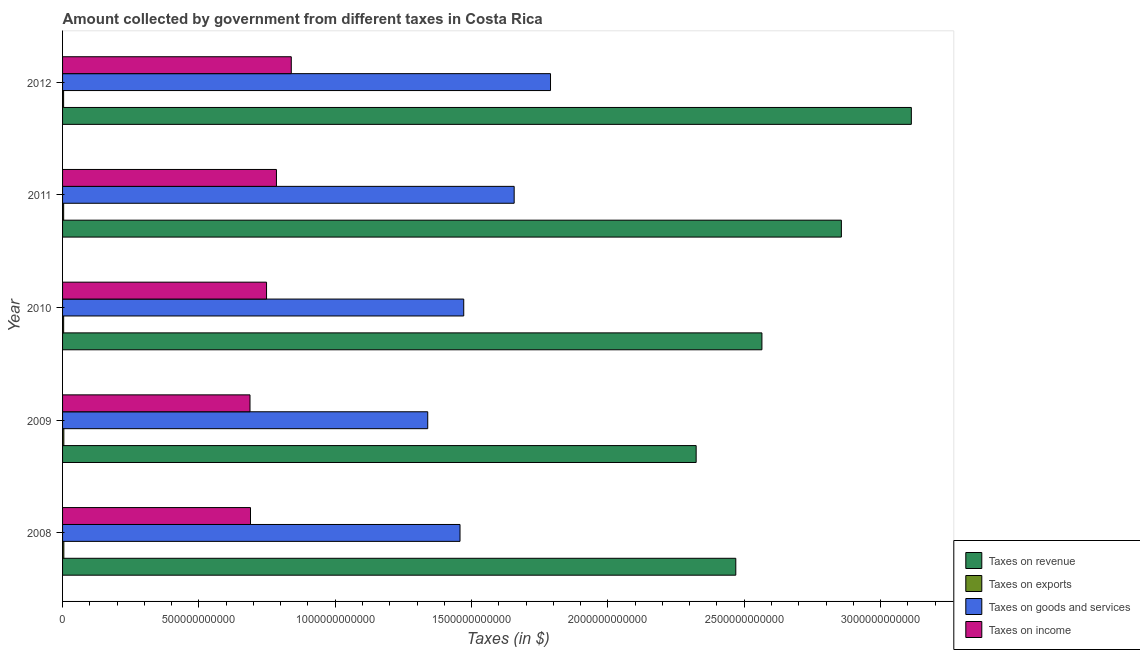How many different coloured bars are there?
Your response must be concise. 4. How many bars are there on the 1st tick from the bottom?
Keep it short and to the point. 4. What is the amount collected as tax on revenue in 2009?
Offer a terse response. 2.32e+12. Across all years, what is the maximum amount collected as tax on revenue?
Provide a succinct answer. 3.11e+12. Across all years, what is the minimum amount collected as tax on revenue?
Offer a terse response. 2.32e+12. What is the total amount collected as tax on exports in the graph?
Provide a succinct answer. 2.11e+1. What is the difference between the amount collected as tax on revenue in 2010 and that in 2011?
Your response must be concise. -2.91e+11. What is the difference between the amount collected as tax on revenue in 2012 and the amount collected as tax on income in 2011?
Your answer should be very brief. 2.33e+12. What is the average amount collected as tax on goods per year?
Provide a short and direct response. 1.54e+12. In the year 2008, what is the difference between the amount collected as tax on revenue and amount collected as tax on exports?
Your response must be concise. 2.46e+12. What is the ratio of the amount collected as tax on exports in 2010 to that in 2012?
Ensure brevity in your answer.  1.04. Is the difference between the amount collected as tax on income in 2010 and 2011 greater than the difference between the amount collected as tax on exports in 2010 and 2011?
Give a very brief answer. No. What is the difference between the highest and the second highest amount collected as tax on revenue?
Your response must be concise. 2.57e+11. What is the difference between the highest and the lowest amount collected as tax on income?
Offer a very short reply. 1.51e+11. What does the 1st bar from the top in 2009 represents?
Offer a very short reply. Taxes on income. What does the 2nd bar from the bottom in 2011 represents?
Ensure brevity in your answer.  Taxes on exports. How many bars are there?
Your answer should be very brief. 20. Are all the bars in the graph horizontal?
Make the answer very short. Yes. How many years are there in the graph?
Your answer should be compact. 5. What is the difference between two consecutive major ticks on the X-axis?
Your answer should be compact. 5.00e+11. Are the values on the major ticks of X-axis written in scientific E-notation?
Ensure brevity in your answer.  No. Does the graph contain any zero values?
Your answer should be very brief. No. Does the graph contain grids?
Make the answer very short. No. Where does the legend appear in the graph?
Give a very brief answer. Bottom right. How are the legend labels stacked?
Provide a short and direct response. Vertical. What is the title of the graph?
Offer a terse response. Amount collected by government from different taxes in Costa Rica. Does "Goods and services" appear as one of the legend labels in the graph?
Offer a very short reply. No. What is the label or title of the X-axis?
Make the answer very short. Taxes (in $). What is the Taxes (in $) in Taxes on revenue in 2008?
Provide a succinct answer. 2.47e+12. What is the Taxes (in $) of Taxes on exports in 2008?
Keep it short and to the point. 4.67e+09. What is the Taxes (in $) in Taxes on goods and services in 2008?
Offer a terse response. 1.46e+12. What is the Taxes (in $) of Taxes on income in 2008?
Your answer should be very brief. 6.89e+11. What is the Taxes (in $) of Taxes on revenue in 2009?
Make the answer very short. 2.32e+12. What is the Taxes (in $) in Taxes on exports in 2009?
Your answer should be compact. 4.68e+09. What is the Taxes (in $) in Taxes on goods and services in 2009?
Ensure brevity in your answer.  1.34e+12. What is the Taxes (in $) in Taxes on income in 2009?
Provide a succinct answer. 6.87e+11. What is the Taxes (in $) in Taxes on revenue in 2010?
Offer a very short reply. 2.56e+12. What is the Taxes (in $) in Taxes on exports in 2010?
Your response must be concise. 3.97e+09. What is the Taxes (in $) in Taxes on goods and services in 2010?
Offer a terse response. 1.47e+12. What is the Taxes (in $) in Taxes on income in 2010?
Your response must be concise. 7.48e+11. What is the Taxes (in $) of Taxes on revenue in 2011?
Keep it short and to the point. 2.86e+12. What is the Taxes (in $) of Taxes on exports in 2011?
Provide a succinct answer. 3.99e+09. What is the Taxes (in $) of Taxes on goods and services in 2011?
Keep it short and to the point. 1.66e+12. What is the Taxes (in $) in Taxes on income in 2011?
Offer a very short reply. 7.84e+11. What is the Taxes (in $) of Taxes on revenue in 2012?
Your answer should be compact. 3.11e+12. What is the Taxes (in $) in Taxes on exports in 2012?
Your answer should be very brief. 3.82e+09. What is the Taxes (in $) of Taxes on goods and services in 2012?
Make the answer very short. 1.79e+12. What is the Taxes (in $) in Taxes on income in 2012?
Provide a succinct answer. 8.39e+11. Across all years, what is the maximum Taxes (in $) of Taxes on revenue?
Provide a short and direct response. 3.11e+12. Across all years, what is the maximum Taxes (in $) in Taxes on exports?
Provide a succinct answer. 4.68e+09. Across all years, what is the maximum Taxes (in $) in Taxes on goods and services?
Your answer should be very brief. 1.79e+12. Across all years, what is the maximum Taxes (in $) of Taxes on income?
Give a very brief answer. 8.39e+11. Across all years, what is the minimum Taxes (in $) in Taxes on revenue?
Ensure brevity in your answer.  2.32e+12. Across all years, what is the minimum Taxes (in $) of Taxes on exports?
Offer a terse response. 3.82e+09. Across all years, what is the minimum Taxes (in $) of Taxes on goods and services?
Provide a short and direct response. 1.34e+12. Across all years, what is the minimum Taxes (in $) of Taxes on income?
Provide a short and direct response. 6.87e+11. What is the total Taxes (in $) in Taxes on revenue in the graph?
Give a very brief answer. 1.33e+13. What is the total Taxes (in $) of Taxes on exports in the graph?
Provide a succinct answer. 2.11e+1. What is the total Taxes (in $) in Taxes on goods and services in the graph?
Offer a terse response. 7.71e+12. What is the total Taxes (in $) in Taxes on income in the graph?
Your response must be concise. 3.75e+12. What is the difference between the Taxes (in $) in Taxes on revenue in 2008 and that in 2009?
Give a very brief answer. 1.45e+11. What is the difference between the Taxes (in $) of Taxes on exports in 2008 and that in 2009?
Offer a terse response. -9.87e+06. What is the difference between the Taxes (in $) in Taxes on goods and services in 2008 and that in 2009?
Offer a terse response. 1.18e+11. What is the difference between the Taxes (in $) of Taxes on income in 2008 and that in 2009?
Keep it short and to the point. 1.80e+09. What is the difference between the Taxes (in $) of Taxes on revenue in 2008 and that in 2010?
Ensure brevity in your answer.  -9.58e+1. What is the difference between the Taxes (in $) of Taxes on exports in 2008 and that in 2010?
Give a very brief answer. 6.95e+08. What is the difference between the Taxes (in $) in Taxes on goods and services in 2008 and that in 2010?
Keep it short and to the point. -1.36e+1. What is the difference between the Taxes (in $) in Taxes on income in 2008 and that in 2010?
Offer a very short reply. -5.89e+1. What is the difference between the Taxes (in $) in Taxes on revenue in 2008 and that in 2011?
Ensure brevity in your answer.  -3.87e+11. What is the difference between the Taxes (in $) of Taxes on exports in 2008 and that in 2011?
Offer a very short reply. 6.77e+08. What is the difference between the Taxes (in $) of Taxes on goods and services in 2008 and that in 2011?
Provide a short and direct response. -1.99e+11. What is the difference between the Taxes (in $) of Taxes on income in 2008 and that in 2011?
Make the answer very short. -9.52e+1. What is the difference between the Taxes (in $) in Taxes on revenue in 2008 and that in 2012?
Keep it short and to the point. -6.44e+11. What is the difference between the Taxes (in $) in Taxes on exports in 2008 and that in 2012?
Your answer should be compact. 8.44e+08. What is the difference between the Taxes (in $) of Taxes on goods and services in 2008 and that in 2012?
Offer a very short reply. -3.32e+11. What is the difference between the Taxes (in $) in Taxes on income in 2008 and that in 2012?
Offer a very short reply. -1.50e+11. What is the difference between the Taxes (in $) in Taxes on revenue in 2009 and that in 2010?
Make the answer very short. -2.41e+11. What is the difference between the Taxes (in $) of Taxes on exports in 2009 and that in 2010?
Keep it short and to the point. 7.04e+08. What is the difference between the Taxes (in $) in Taxes on goods and services in 2009 and that in 2010?
Provide a short and direct response. -1.32e+11. What is the difference between the Taxes (in $) of Taxes on income in 2009 and that in 2010?
Your answer should be very brief. -6.07e+1. What is the difference between the Taxes (in $) of Taxes on revenue in 2009 and that in 2011?
Your response must be concise. -5.33e+11. What is the difference between the Taxes (in $) in Taxes on exports in 2009 and that in 2011?
Make the answer very short. 6.87e+08. What is the difference between the Taxes (in $) in Taxes on goods and services in 2009 and that in 2011?
Offer a terse response. -3.17e+11. What is the difference between the Taxes (in $) of Taxes on income in 2009 and that in 2011?
Provide a short and direct response. -9.70e+1. What is the difference between the Taxes (in $) of Taxes on revenue in 2009 and that in 2012?
Provide a short and direct response. -7.89e+11. What is the difference between the Taxes (in $) in Taxes on exports in 2009 and that in 2012?
Offer a very short reply. 8.54e+08. What is the difference between the Taxes (in $) in Taxes on goods and services in 2009 and that in 2012?
Offer a terse response. -4.50e+11. What is the difference between the Taxes (in $) in Taxes on income in 2009 and that in 2012?
Offer a very short reply. -1.51e+11. What is the difference between the Taxes (in $) in Taxes on revenue in 2010 and that in 2011?
Ensure brevity in your answer.  -2.91e+11. What is the difference between the Taxes (in $) in Taxes on exports in 2010 and that in 2011?
Make the answer very short. -1.76e+07. What is the difference between the Taxes (in $) of Taxes on goods and services in 2010 and that in 2011?
Ensure brevity in your answer.  -1.85e+11. What is the difference between the Taxes (in $) in Taxes on income in 2010 and that in 2011?
Your answer should be very brief. -3.63e+1. What is the difference between the Taxes (in $) in Taxes on revenue in 2010 and that in 2012?
Keep it short and to the point. -5.48e+11. What is the difference between the Taxes (in $) in Taxes on exports in 2010 and that in 2012?
Your answer should be compact. 1.49e+08. What is the difference between the Taxes (in $) in Taxes on goods and services in 2010 and that in 2012?
Make the answer very short. -3.18e+11. What is the difference between the Taxes (in $) in Taxes on income in 2010 and that in 2012?
Ensure brevity in your answer.  -9.07e+1. What is the difference between the Taxes (in $) in Taxes on revenue in 2011 and that in 2012?
Your response must be concise. -2.57e+11. What is the difference between the Taxes (in $) of Taxes on exports in 2011 and that in 2012?
Your answer should be very brief. 1.67e+08. What is the difference between the Taxes (in $) in Taxes on goods and services in 2011 and that in 2012?
Ensure brevity in your answer.  -1.33e+11. What is the difference between the Taxes (in $) of Taxes on income in 2011 and that in 2012?
Ensure brevity in your answer.  -5.44e+1. What is the difference between the Taxes (in $) in Taxes on revenue in 2008 and the Taxes (in $) in Taxes on exports in 2009?
Your answer should be very brief. 2.46e+12. What is the difference between the Taxes (in $) of Taxes on revenue in 2008 and the Taxes (in $) of Taxes on goods and services in 2009?
Provide a succinct answer. 1.13e+12. What is the difference between the Taxes (in $) in Taxes on revenue in 2008 and the Taxes (in $) in Taxes on income in 2009?
Provide a succinct answer. 1.78e+12. What is the difference between the Taxes (in $) of Taxes on exports in 2008 and the Taxes (in $) of Taxes on goods and services in 2009?
Ensure brevity in your answer.  -1.33e+12. What is the difference between the Taxes (in $) in Taxes on exports in 2008 and the Taxes (in $) in Taxes on income in 2009?
Your answer should be compact. -6.83e+11. What is the difference between the Taxes (in $) in Taxes on goods and services in 2008 and the Taxes (in $) in Taxes on income in 2009?
Your response must be concise. 7.70e+11. What is the difference between the Taxes (in $) of Taxes on revenue in 2008 and the Taxes (in $) of Taxes on exports in 2010?
Provide a short and direct response. 2.47e+12. What is the difference between the Taxes (in $) of Taxes on revenue in 2008 and the Taxes (in $) of Taxes on goods and services in 2010?
Offer a terse response. 9.98e+11. What is the difference between the Taxes (in $) of Taxes on revenue in 2008 and the Taxes (in $) of Taxes on income in 2010?
Your answer should be compact. 1.72e+12. What is the difference between the Taxes (in $) in Taxes on exports in 2008 and the Taxes (in $) in Taxes on goods and services in 2010?
Provide a succinct answer. -1.47e+12. What is the difference between the Taxes (in $) of Taxes on exports in 2008 and the Taxes (in $) of Taxes on income in 2010?
Give a very brief answer. -7.43e+11. What is the difference between the Taxes (in $) in Taxes on goods and services in 2008 and the Taxes (in $) in Taxes on income in 2010?
Offer a very short reply. 7.10e+11. What is the difference between the Taxes (in $) of Taxes on revenue in 2008 and the Taxes (in $) of Taxes on exports in 2011?
Offer a terse response. 2.47e+12. What is the difference between the Taxes (in $) in Taxes on revenue in 2008 and the Taxes (in $) in Taxes on goods and services in 2011?
Offer a terse response. 8.13e+11. What is the difference between the Taxes (in $) in Taxes on revenue in 2008 and the Taxes (in $) in Taxes on income in 2011?
Your answer should be compact. 1.68e+12. What is the difference between the Taxes (in $) of Taxes on exports in 2008 and the Taxes (in $) of Taxes on goods and services in 2011?
Your answer should be very brief. -1.65e+12. What is the difference between the Taxes (in $) in Taxes on exports in 2008 and the Taxes (in $) in Taxes on income in 2011?
Your response must be concise. -7.80e+11. What is the difference between the Taxes (in $) in Taxes on goods and services in 2008 and the Taxes (in $) in Taxes on income in 2011?
Give a very brief answer. 6.73e+11. What is the difference between the Taxes (in $) in Taxes on revenue in 2008 and the Taxes (in $) in Taxes on exports in 2012?
Your answer should be compact. 2.47e+12. What is the difference between the Taxes (in $) in Taxes on revenue in 2008 and the Taxes (in $) in Taxes on goods and services in 2012?
Give a very brief answer. 6.79e+11. What is the difference between the Taxes (in $) of Taxes on revenue in 2008 and the Taxes (in $) of Taxes on income in 2012?
Give a very brief answer. 1.63e+12. What is the difference between the Taxes (in $) in Taxes on exports in 2008 and the Taxes (in $) in Taxes on goods and services in 2012?
Offer a terse response. -1.78e+12. What is the difference between the Taxes (in $) of Taxes on exports in 2008 and the Taxes (in $) of Taxes on income in 2012?
Ensure brevity in your answer.  -8.34e+11. What is the difference between the Taxes (in $) in Taxes on goods and services in 2008 and the Taxes (in $) in Taxes on income in 2012?
Your response must be concise. 6.19e+11. What is the difference between the Taxes (in $) of Taxes on revenue in 2009 and the Taxes (in $) of Taxes on exports in 2010?
Your answer should be compact. 2.32e+12. What is the difference between the Taxes (in $) in Taxes on revenue in 2009 and the Taxes (in $) in Taxes on goods and services in 2010?
Make the answer very short. 8.52e+11. What is the difference between the Taxes (in $) in Taxes on revenue in 2009 and the Taxes (in $) in Taxes on income in 2010?
Keep it short and to the point. 1.58e+12. What is the difference between the Taxes (in $) in Taxes on exports in 2009 and the Taxes (in $) in Taxes on goods and services in 2010?
Your answer should be compact. -1.47e+12. What is the difference between the Taxes (in $) in Taxes on exports in 2009 and the Taxes (in $) in Taxes on income in 2010?
Offer a very short reply. -7.43e+11. What is the difference between the Taxes (in $) in Taxes on goods and services in 2009 and the Taxes (in $) in Taxes on income in 2010?
Provide a short and direct response. 5.91e+11. What is the difference between the Taxes (in $) of Taxes on revenue in 2009 and the Taxes (in $) of Taxes on exports in 2011?
Offer a terse response. 2.32e+12. What is the difference between the Taxes (in $) of Taxes on revenue in 2009 and the Taxes (in $) of Taxes on goods and services in 2011?
Keep it short and to the point. 6.67e+11. What is the difference between the Taxes (in $) of Taxes on revenue in 2009 and the Taxes (in $) of Taxes on income in 2011?
Make the answer very short. 1.54e+12. What is the difference between the Taxes (in $) in Taxes on exports in 2009 and the Taxes (in $) in Taxes on goods and services in 2011?
Provide a short and direct response. -1.65e+12. What is the difference between the Taxes (in $) of Taxes on exports in 2009 and the Taxes (in $) of Taxes on income in 2011?
Ensure brevity in your answer.  -7.80e+11. What is the difference between the Taxes (in $) of Taxes on goods and services in 2009 and the Taxes (in $) of Taxes on income in 2011?
Your answer should be compact. 5.55e+11. What is the difference between the Taxes (in $) in Taxes on revenue in 2009 and the Taxes (in $) in Taxes on exports in 2012?
Offer a very short reply. 2.32e+12. What is the difference between the Taxes (in $) in Taxes on revenue in 2009 and the Taxes (in $) in Taxes on goods and services in 2012?
Make the answer very short. 5.34e+11. What is the difference between the Taxes (in $) in Taxes on revenue in 2009 and the Taxes (in $) in Taxes on income in 2012?
Offer a terse response. 1.48e+12. What is the difference between the Taxes (in $) of Taxes on exports in 2009 and the Taxes (in $) of Taxes on goods and services in 2012?
Your answer should be very brief. -1.78e+12. What is the difference between the Taxes (in $) in Taxes on exports in 2009 and the Taxes (in $) in Taxes on income in 2012?
Offer a very short reply. -8.34e+11. What is the difference between the Taxes (in $) in Taxes on goods and services in 2009 and the Taxes (in $) in Taxes on income in 2012?
Your answer should be compact. 5.00e+11. What is the difference between the Taxes (in $) in Taxes on revenue in 2010 and the Taxes (in $) in Taxes on exports in 2011?
Make the answer very short. 2.56e+12. What is the difference between the Taxes (in $) of Taxes on revenue in 2010 and the Taxes (in $) of Taxes on goods and services in 2011?
Offer a very short reply. 9.09e+11. What is the difference between the Taxes (in $) in Taxes on revenue in 2010 and the Taxes (in $) in Taxes on income in 2011?
Offer a very short reply. 1.78e+12. What is the difference between the Taxes (in $) in Taxes on exports in 2010 and the Taxes (in $) in Taxes on goods and services in 2011?
Your answer should be compact. -1.65e+12. What is the difference between the Taxes (in $) of Taxes on exports in 2010 and the Taxes (in $) of Taxes on income in 2011?
Your answer should be compact. -7.80e+11. What is the difference between the Taxes (in $) in Taxes on goods and services in 2010 and the Taxes (in $) in Taxes on income in 2011?
Your response must be concise. 6.87e+11. What is the difference between the Taxes (in $) of Taxes on revenue in 2010 and the Taxes (in $) of Taxes on exports in 2012?
Keep it short and to the point. 2.56e+12. What is the difference between the Taxes (in $) of Taxes on revenue in 2010 and the Taxes (in $) of Taxes on goods and services in 2012?
Offer a terse response. 7.75e+11. What is the difference between the Taxes (in $) of Taxes on revenue in 2010 and the Taxes (in $) of Taxes on income in 2012?
Your answer should be compact. 1.73e+12. What is the difference between the Taxes (in $) in Taxes on exports in 2010 and the Taxes (in $) in Taxes on goods and services in 2012?
Provide a short and direct response. -1.79e+12. What is the difference between the Taxes (in $) of Taxes on exports in 2010 and the Taxes (in $) of Taxes on income in 2012?
Ensure brevity in your answer.  -8.35e+11. What is the difference between the Taxes (in $) of Taxes on goods and services in 2010 and the Taxes (in $) of Taxes on income in 2012?
Your response must be concise. 6.32e+11. What is the difference between the Taxes (in $) of Taxes on revenue in 2011 and the Taxes (in $) of Taxes on exports in 2012?
Your answer should be compact. 2.85e+12. What is the difference between the Taxes (in $) in Taxes on revenue in 2011 and the Taxes (in $) in Taxes on goods and services in 2012?
Offer a very short reply. 1.07e+12. What is the difference between the Taxes (in $) of Taxes on revenue in 2011 and the Taxes (in $) of Taxes on income in 2012?
Offer a terse response. 2.02e+12. What is the difference between the Taxes (in $) of Taxes on exports in 2011 and the Taxes (in $) of Taxes on goods and services in 2012?
Keep it short and to the point. -1.79e+12. What is the difference between the Taxes (in $) in Taxes on exports in 2011 and the Taxes (in $) in Taxes on income in 2012?
Give a very brief answer. -8.35e+11. What is the difference between the Taxes (in $) in Taxes on goods and services in 2011 and the Taxes (in $) in Taxes on income in 2012?
Ensure brevity in your answer.  8.17e+11. What is the average Taxes (in $) of Taxes on revenue per year?
Your answer should be compact. 2.67e+12. What is the average Taxes (in $) in Taxes on exports per year?
Make the answer very short. 4.23e+09. What is the average Taxes (in $) of Taxes on goods and services per year?
Offer a very short reply. 1.54e+12. What is the average Taxes (in $) of Taxes on income per year?
Offer a very short reply. 7.50e+11. In the year 2008, what is the difference between the Taxes (in $) in Taxes on revenue and Taxes (in $) in Taxes on exports?
Give a very brief answer. 2.46e+12. In the year 2008, what is the difference between the Taxes (in $) of Taxes on revenue and Taxes (in $) of Taxes on goods and services?
Give a very brief answer. 1.01e+12. In the year 2008, what is the difference between the Taxes (in $) of Taxes on revenue and Taxes (in $) of Taxes on income?
Provide a short and direct response. 1.78e+12. In the year 2008, what is the difference between the Taxes (in $) of Taxes on exports and Taxes (in $) of Taxes on goods and services?
Offer a terse response. -1.45e+12. In the year 2008, what is the difference between the Taxes (in $) in Taxes on exports and Taxes (in $) in Taxes on income?
Give a very brief answer. -6.85e+11. In the year 2008, what is the difference between the Taxes (in $) of Taxes on goods and services and Taxes (in $) of Taxes on income?
Give a very brief answer. 7.68e+11. In the year 2009, what is the difference between the Taxes (in $) in Taxes on revenue and Taxes (in $) in Taxes on exports?
Your answer should be compact. 2.32e+12. In the year 2009, what is the difference between the Taxes (in $) of Taxes on revenue and Taxes (in $) of Taxes on goods and services?
Offer a terse response. 9.84e+11. In the year 2009, what is the difference between the Taxes (in $) of Taxes on revenue and Taxes (in $) of Taxes on income?
Provide a short and direct response. 1.64e+12. In the year 2009, what is the difference between the Taxes (in $) in Taxes on exports and Taxes (in $) in Taxes on goods and services?
Make the answer very short. -1.33e+12. In the year 2009, what is the difference between the Taxes (in $) in Taxes on exports and Taxes (in $) in Taxes on income?
Your answer should be compact. -6.83e+11. In the year 2009, what is the difference between the Taxes (in $) in Taxes on goods and services and Taxes (in $) in Taxes on income?
Make the answer very short. 6.52e+11. In the year 2010, what is the difference between the Taxes (in $) in Taxes on revenue and Taxes (in $) in Taxes on exports?
Offer a very short reply. 2.56e+12. In the year 2010, what is the difference between the Taxes (in $) of Taxes on revenue and Taxes (in $) of Taxes on goods and services?
Provide a short and direct response. 1.09e+12. In the year 2010, what is the difference between the Taxes (in $) in Taxes on revenue and Taxes (in $) in Taxes on income?
Offer a terse response. 1.82e+12. In the year 2010, what is the difference between the Taxes (in $) of Taxes on exports and Taxes (in $) of Taxes on goods and services?
Keep it short and to the point. -1.47e+12. In the year 2010, what is the difference between the Taxes (in $) of Taxes on exports and Taxes (in $) of Taxes on income?
Provide a succinct answer. -7.44e+11. In the year 2010, what is the difference between the Taxes (in $) in Taxes on goods and services and Taxes (in $) in Taxes on income?
Your answer should be very brief. 7.23e+11. In the year 2011, what is the difference between the Taxes (in $) in Taxes on revenue and Taxes (in $) in Taxes on exports?
Offer a terse response. 2.85e+12. In the year 2011, what is the difference between the Taxes (in $) in Taxes on revenue and Taxes (in $) in Taxes on goods and services?
Give a very brief answer. 1.20e+12. In the year 2011, what is the difference between the Taxes (in $) in Taxes on revenue and Taxes (in $) in Taxes on income?
Ensure brevity in your answer.  2.07e+12. In the year 2011, what is the difference between the Taxes (in $) in Taxes on exports and Taxes (in $) in Taxes on goods and services?
Make the answer very short. -1.65e+12. In the year 2011, what is the difference between the Taxes (in $) of Taxes on exports and Taxes (in $) of Taxes on income?
Offer a very short reply. -7.80e+11. In the year 2011, what is the difference between the Taxes (in $) of Taxes on goods and services and Taxes (in $) of Taxes on income?
Ensure brevity in your answer.  8.72e+11. In the year 2012, what is the difference between the Taxes (in $) in Taxes on revenue and Taxes (in $) in Taxes on exports?
Provide a short and direct response. 3.11e+12. In the year 2012, what is the difference between the Taxes (in $) in Taxes on revenue and Taxes (in $) in Taxes on goods and services?
Make the answer very short. 1.32e+12. In the year 2012, what is the difference between the Taxes (in $) in Taxes on revenue and Taxes (in $) in Taxes on income?
Offer a very short reply. 2.27e+12. In the year 2012, what is the difference between the Taxes (in $) of Taxes on exports and Taxes (in $) of Taxes on goods and services?
Your answer should be very brief. -1.79e+12. In the year 2012, what is the difference between the Taxes (in $) in Taxes on exports and Taxes (in $) in Taxes on income?
Give a very brief answer. -8.35e+11. In the year 2012, what is the difference between the Taxes (in $) of Taxes on goods and services and Taxes (in $) of Taxes on income?
Your response must be concise. 9.51e+11. What is the ratio of the Taxes (in $) in Taxes on revenue in 2008 to that in 2009?
Your response must be concise. 1.06. What is the ratio of the Taxes (in $) in Taxes on goods and services in 2008 to that in 2009?
Offer a terse response. 1.09. What is the ratio of the Taxes (in $) in Taxes on revenue in 2008 to that in 2010?
Provide a succinct answer. 0.96. What is the ratio of the Taxes (in $) of Taxes on exports in 2008 to that in 2010?
Offer a very short reply. 1.17. What is the ratio of the Taxes (in $) of Taxes on goods and services in 2008 to that in 2010?
Your answer should be very brief. 0.99. What is the ratio of the Taxes (in $) of Taxes on income in 2008 to that in 2010?
Provide a short and direct response. 0.92. What is the ratio of the Taxes (in $) of Taxes on revenue in 2008 to that in 2011?
Your answer should be compact. 0.86. What is the ratio of the Taxes (in $) of Taxes on exports in 2008 to that in 2011?
Offer a terse response. 1.17. What is the ratio of the Taxes (in $) of Taxes on goods and services in 2008 to that in 2011?
Keep it short and to the point. 0.88. What is the ratio of the Taxes (in $) in Taxes on income in 2008 to that in 2011?
Your answer should be very brief. 0.88. What is the ratio of the Taxes (in $) of Taxes on revenue in 2008 to that in 2012?
Keep it short and to the point. 0.79. What is the ratio of the Taxes (in $) of Taxes on exports in 2008 to that in 2012?
Your response must be concise. 1.22. What is the ratio of the Taxes (in $) of Taxes on goods and services in 2008 to that in 2012?
Make the answer very short. 0.81. What is the ratio of the Taxes (in $) in Taxes on income in 2008 to that in 2012?
Offer a terse response. 0.82. What is the ratio of the Taxes (in $) in Taxes on revenue in 2009 to that in 2010?
Provide a succinct answer. 0.91. What is the ratio of the Taxes (in $) in Taxes on exports in 2009 to that in 2010?
Ensure brevity in your answer.  1.18. What is the ratio of the Taxes (in $) in Taxes on goods and services in 2009 to that in 2010?
Provide a succinct answer. 0.91. What is the ratio of the Taxes (in $) in Taxes on income in 2009 to that in 2010?
Your response must be concise. 0.92. What is the ratio of the Taxes (in $) of Taxes on revenue in 2009 to that in 2011?
Provide a short and direct response. 0.81. What is the ratio of the Taxes (in $) in Taxes on exports in 2009 to that in 2011?
Offer a terse response. 1.17. What is the ratio of the Taxes (in $) in Taxes on goods and services in 2009 to that in 2011?
Keep it short and to the point. 0.81. What is the ratio of the Taxes (in $) in Taxes on income in 2009 to that in 2011?
Make the answer very short. 0.88. What is the ratio of the Taxes (in $) in Taxes on revenue in 2009 to that in 2012?
Your response must be concise. 0.75. What is the ratio of the Taxes (in $) in Taxes on exports in 2009 to that in 2012?
Your answer should be compact. 1.22. What is the ratio of the Taxes (in $) of Taxes on goods and services in 2009 to that in 2012?
Offer a terse response. 0.75. What is the ratio of the Taxes (in $) in Taxes on income in 2009 to that in 2012?
Your answer should be compact. 0.82. What is the ratio of the Taxes (in $) in Taxes on revenue in 2010 to that in 2011?
Ensure brevity in your answer.  0.9. What is the ratio of the Taxes (in $) in Taxes on goods and services in 2010 to that in 2011?
Your response must be concise. 0.89. What is the ratio of the Taxes (in $) in Taxes on income in 2010 to that in 2011?
Offer a terse response. 0.95. What is the ratio of the Taxes (in $) of Taxes on revenue in 2010 to that in 2012?
Your response must be concise. 0.82. What is the ratio of the Taxes (in $) of Taxes on exports in 2010 to that in 2012?
Give a very brief answer. 1.04. What is the ratio of the Taxes (in $) in Taxes on goods and services in 2010 to that in 2012?
Make the answer very short. 0.82. What is the ratio of the Taxes (in $) of Taxes on income in 2010 to that in 2012?
Make the answer very short. 0.89. What is the ratio of the Taxes (in $) of Taxes on revenue in 2011 to that in 2012?
Provide a short and direct response. 0.92. What is the ratio of the Taxes (in $) of Taxes on exports in 2011 to that in 2012?
Your answer should be compact. 1.04. What is the ratio of the Taxes (in $) in Taxes on goods and services in 2011 to that in 2012?
Make the answer very short. 0.93. What is the ratio of the Taxes (in $) in Taxes on income in 2011 to that in 2012?
Ensure brevity in your answer.  0.94. What is the difference between the highest and the second highest Taxes (in $) of Taxes on revenue?
Your answer should be very brief. 2.57e+11. What is the difference between the highest and the second highest Taxes (in $) of Taxes on exports?
Your response must be concise. 9.87e+06. What is the difference between the highest and the second highest Taxes (in $) in Taxes on goods and services?
Your answer should be compact. 1.33e+11. What is the difference between the highest and the second highest Taxes (in $) in Taxes on income?
Provide a short and direct response. 5.44e+1. What is the difference between the highest and the lowest Taxes (in $) of Taxes on revenue?
Give a very brief answer. 7.89e+11. What is the difference between the highest and the lowest Taxes (in $) in Taxes on exports?
Your response must be concise. 8.54e+08. What is the difference between the highest and the lowest Taxes (in $) in Taxes on goods and services?
Your answer should be very brief. 4.50e+11. What is the difference between the highest and the lowest Taxes (in $) in Taxes on income?
Provide a succinct answer. 1.51e+11. 